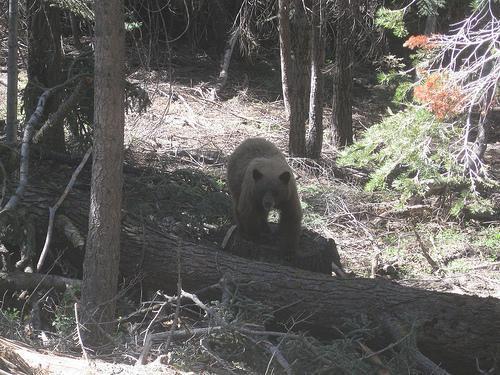How many bears are in the photo?
Give a very brief answer. 1. How many ears does the bear have?
Give a very brief answer. 2. 